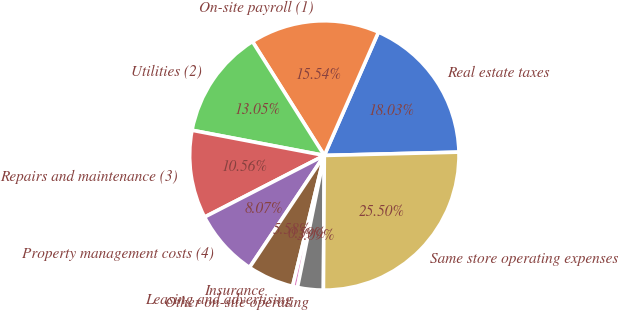<chart> <loc_0><loc_0><loc_500><loc_500><pie_chart><fcel>Real estate taxes<fcel>On-site payroll (1)<fcel>Utilities (2)<fcel>Repairs and maintenance (3)<fcel>Property management costs (4)<fcel>Insurance<fcel>Leasing and advertising<fcel>Other on-site operating<fcel>Same store operating expenses<nl><fcel>18.03%<fcel>15.54%<fcel>13.05%<fcel>10.56%<fcel>8.07%<fcel>5.58%<fcel>0.59%<fcel>3.09%<fcel>25.5%<nl></chart> 